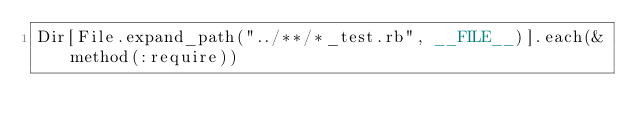<code> <loc_0><loc_0><loc_500><loc_500><_Ruby_>Dir[File.expand_path("../**/*_test.rb", __FILE__)].each(&method(:require))</code> 